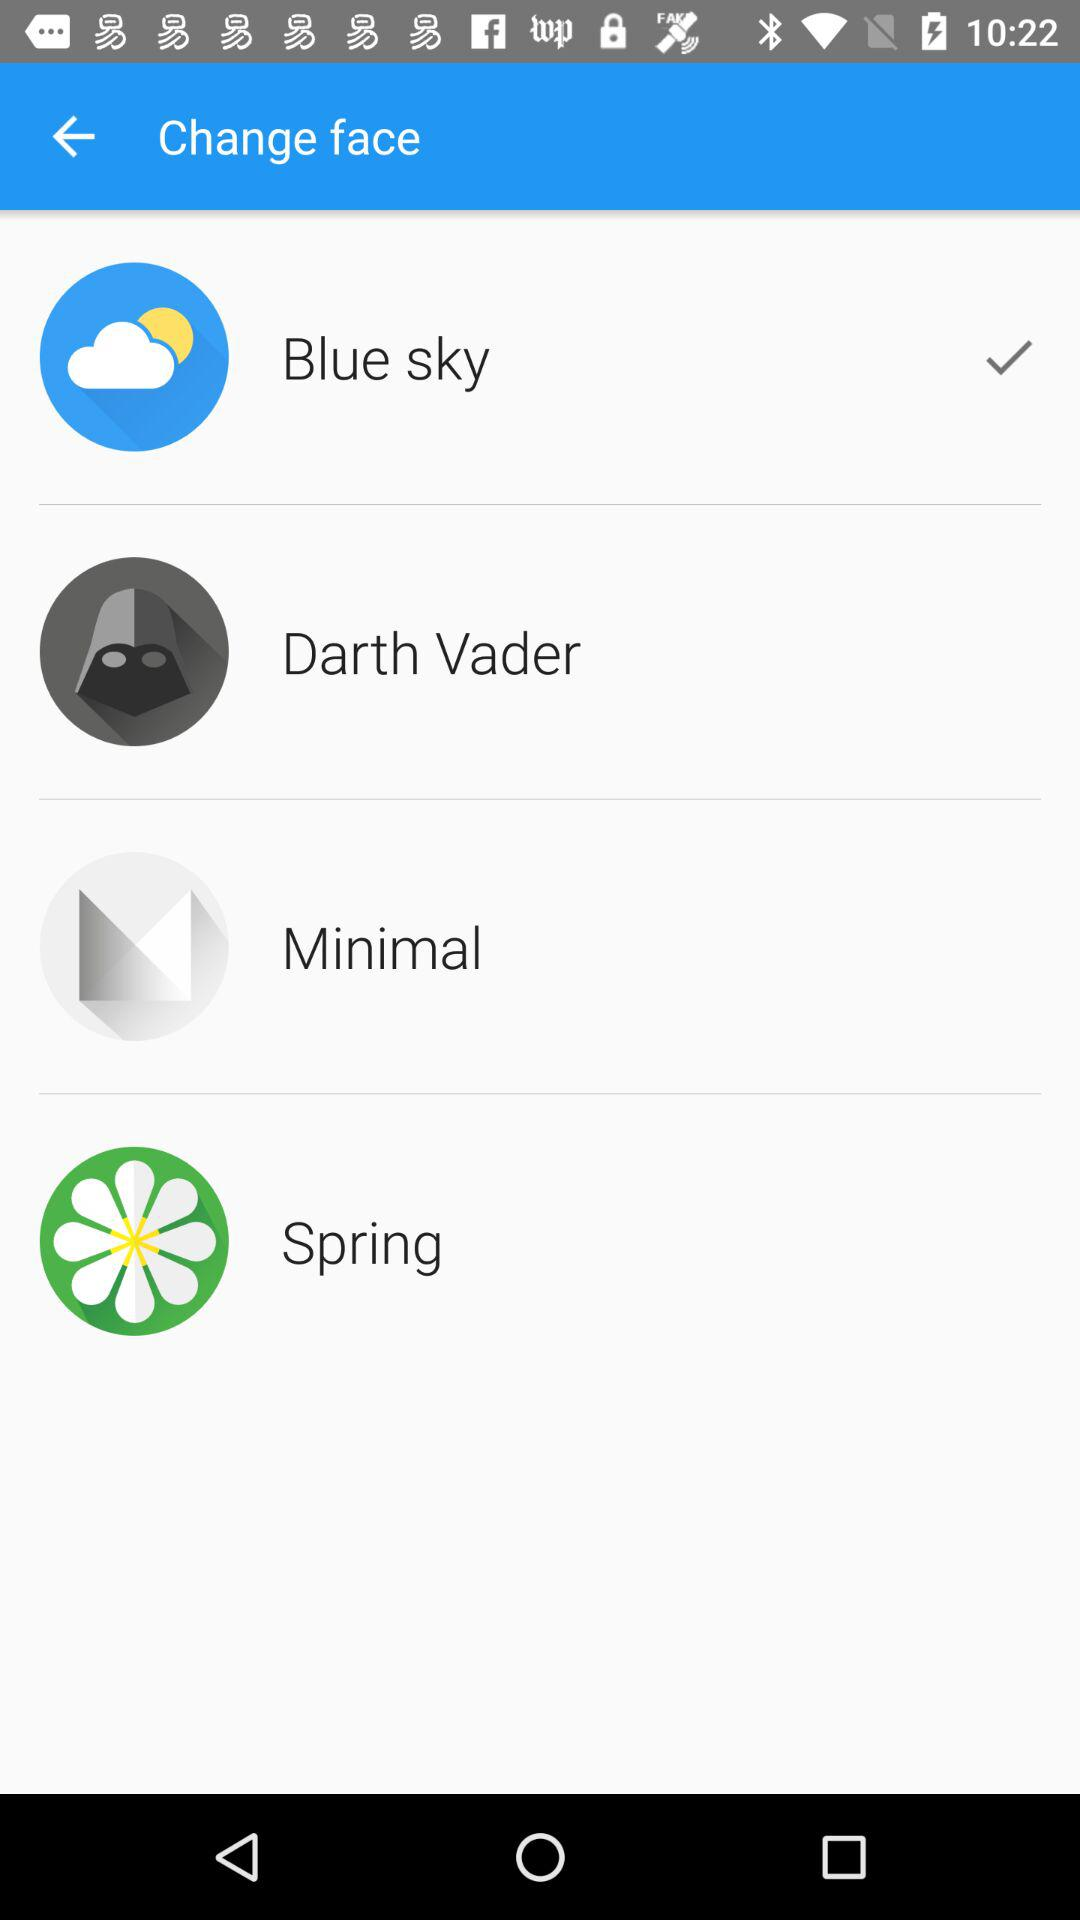Which option has been selected? The option that has been selected is "Blue sky". 